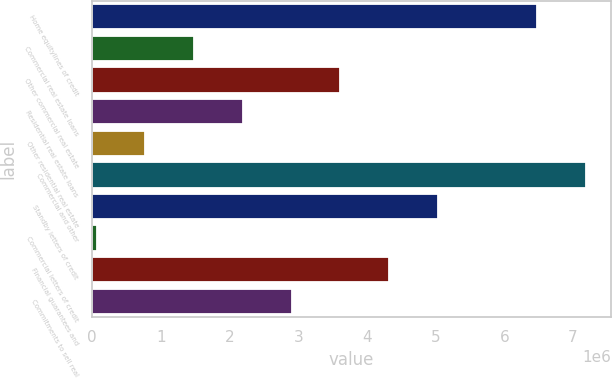Convert chart. <chart><loc_0><loc_0><loc_500><loc_500><bar_chart><fcel>Home equitylines of credit<fcel>Commercial real estate loans<fcel>Other commercial real estate<fcel>Residential real estate loans<fcel>Other residential real estate<fcel>Commercial and other<fcel>Standby letters of credit<fcel>Commercial letters of credit<fcel>Financial guarantees and<fcel>Commitments to sell real<nl><fcel>6.48299e+06<fcel>1.48414e+06<fcel>3.61078e+06<fcel>2.19302e+06<fcel>775258<fcel>7.19187e+06<fcel>5.02854e+06<fcel>66377<fcel>4.31966e+06<fcel>2.9019e+06<nl></chart> 